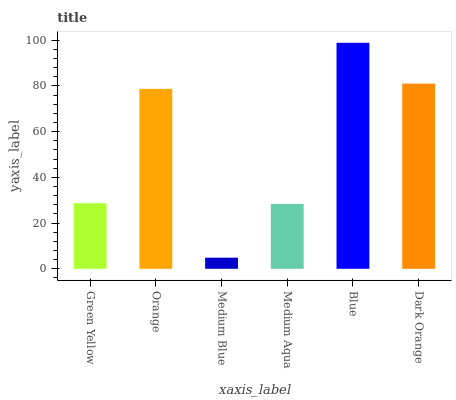Is Medium Blue the minimum?
Answer yes or no. Yes. Is Blue the maximum?
Answer yes or no. Yes. Is Orange the minimum?
Answer yes or no. No. Is Orange the maximum?
Answer yes or no. No. Is Orange greater than Green Yellow?
Answer yes or no. Yes. Is Green Yellow less than Orange?
Answer yes or no. Yes. Is Green Yellow greater than Orange?
Answer yes or no. No. Is Orange less than Green Yellow?
Answer yes or no. No. Is Orange the high median?
Answer yes or no. Yes. Is Green Yellow the low median?
Answer yes or no. Yes. Is Medium Blue the high median?
Answer yes or no. No. Is Medium Aqua the low median?
Answer yes or no. No. 